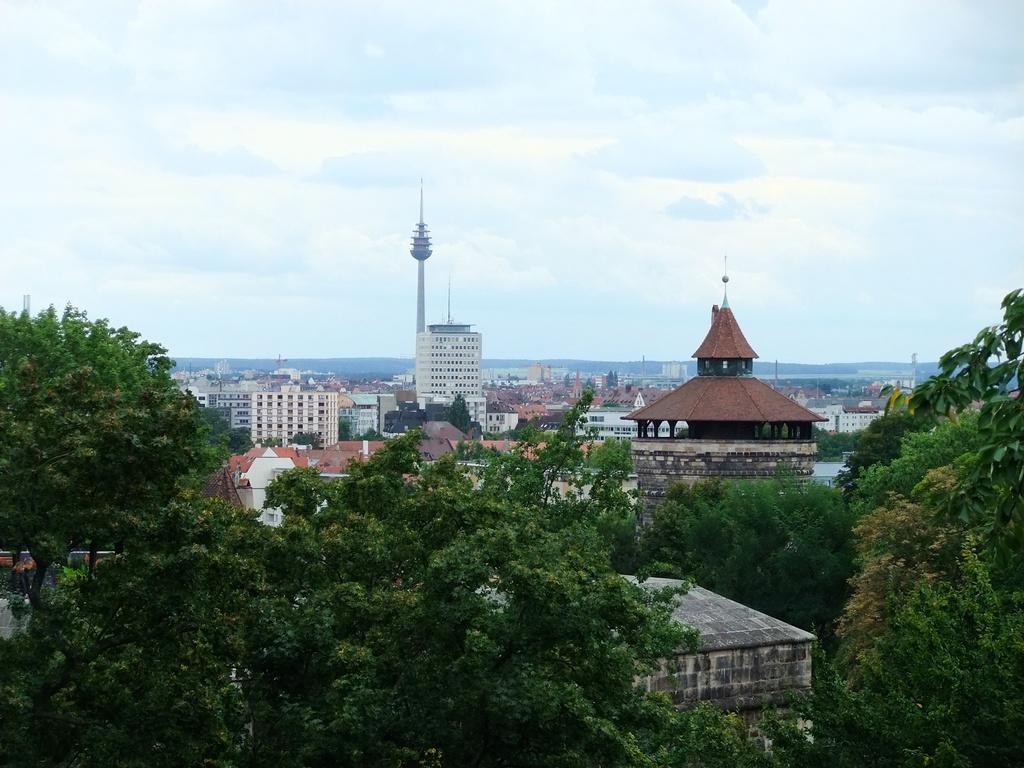Please provide a concise description of this image. In this image there are trees, buildings, tower, hills and sky. 